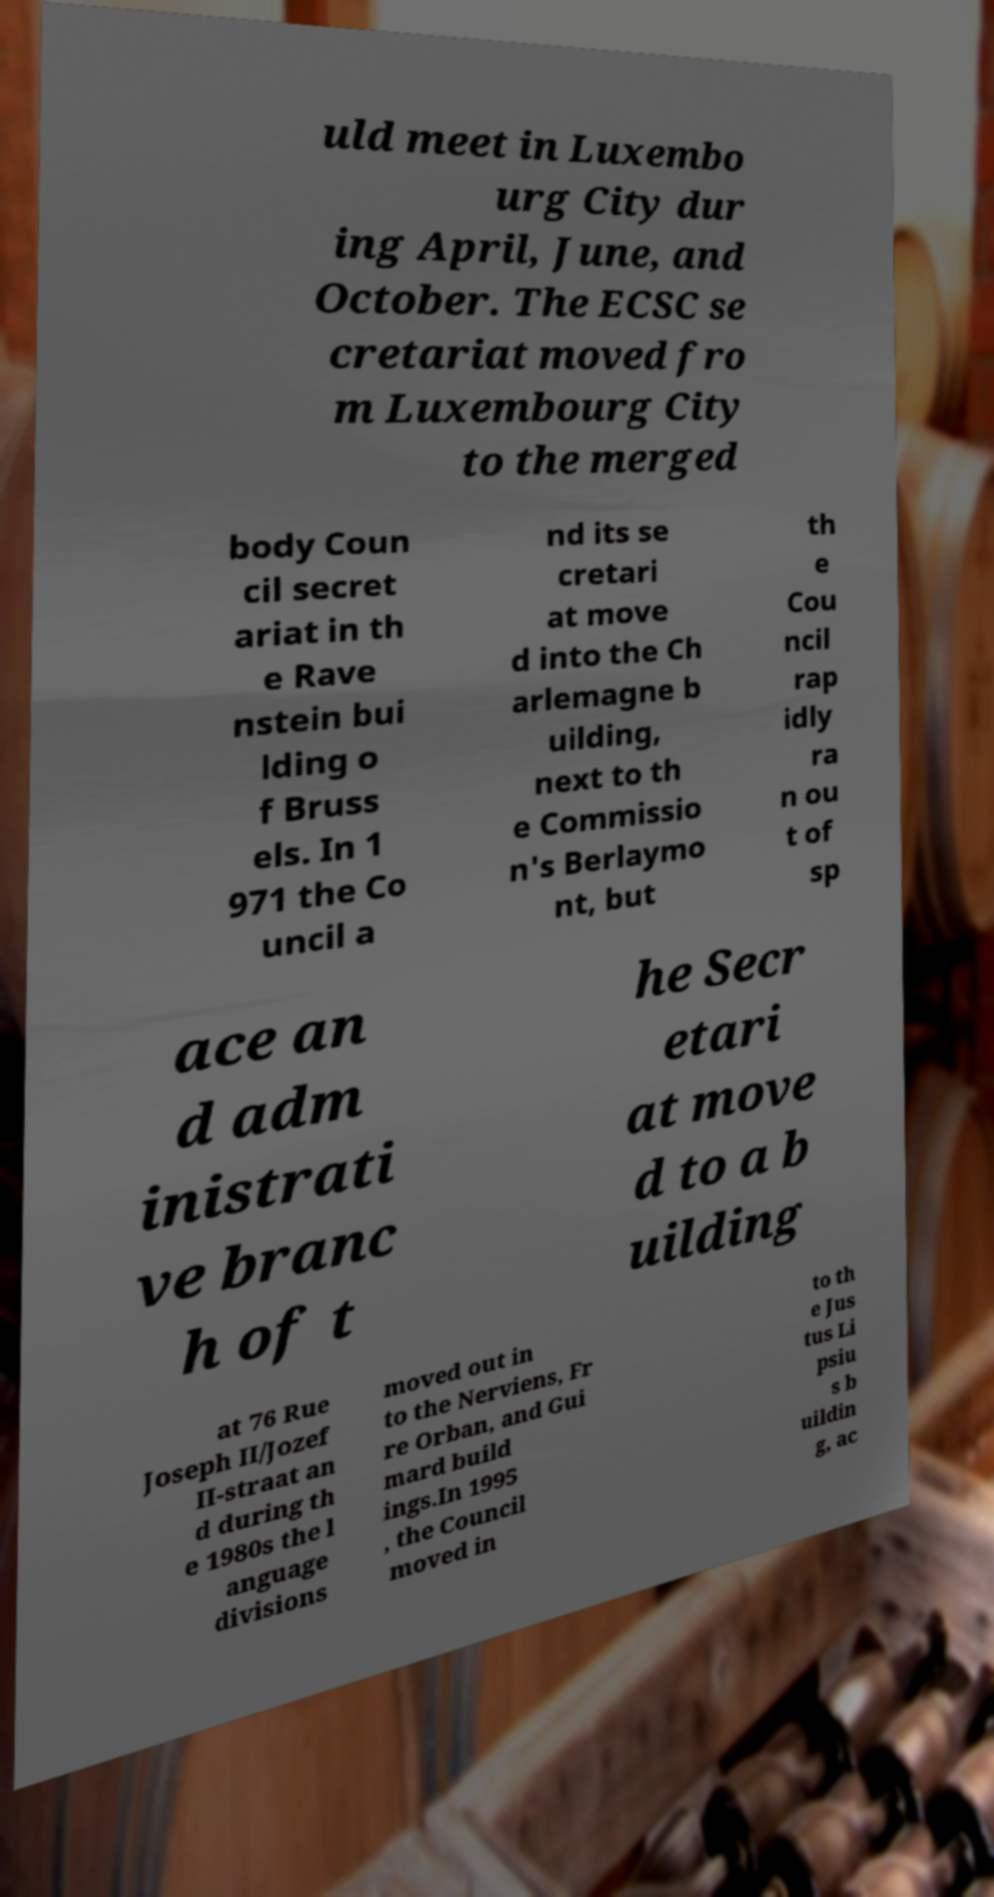What messages or text are displayed in this image? I need them in a readable, typed format. uld meet in Luxembo urg City dur ing April, June, and October. The ECSC se cretariat moved fro m Luxembourg City to the merged body Coun cil secret ariat in th e Rave nstein bui lding o f Bruss els. In 1 971 the Co uncil a nd its se cretari at move d into the Ch arlemagne b uilding, next to th e Commissio n's Berlaymo nt, but th e Cou ncil rap idly ra n ou t of sp ace an d adm inistrati ve branc h of t he Secr etari at move d to a b uilding at 76 Rue Joseph II/Jozef II-straat an d during th e 1980s the l anguage divisions moved out in to the Nerviens, Fr re Orban, and Gui mard build ings.In 1995 , the Council moved in to th e Jus tus Li psiu s b uildin g, ac 